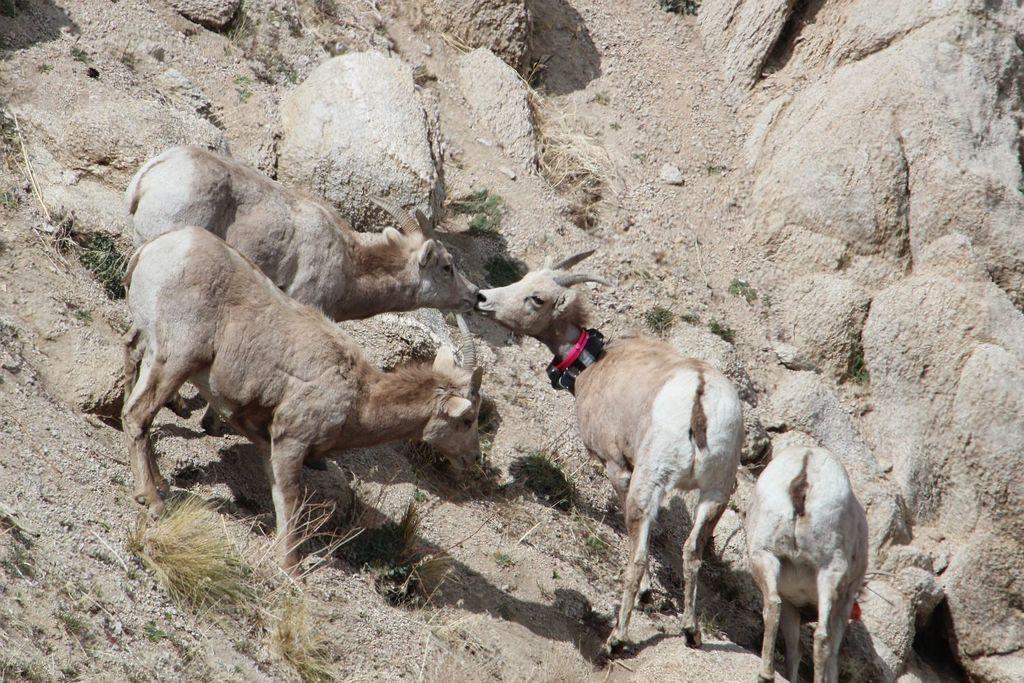Can you describe this image briefly? This image consists of animals. At the bottom, there are rocks. 